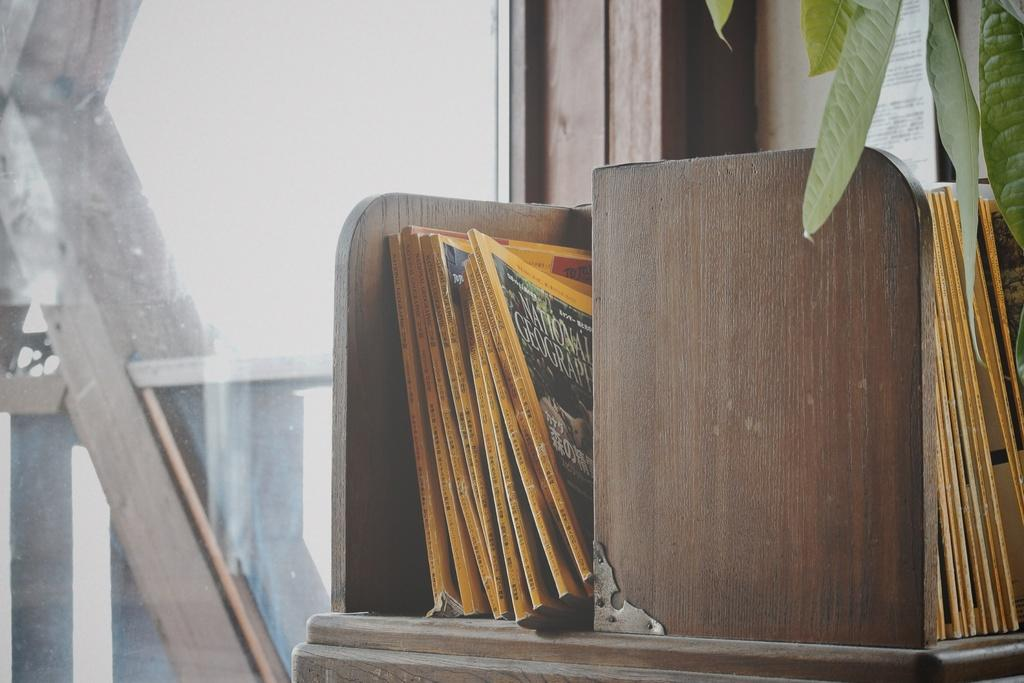What objects are located in the middle of the image? There are books in the middle of the image. What type of vegetation is present in the image? There are green leaves in the image. Where is the glass positioned in the image? The glass is on the left side of the image. How many spiders can be seen crawling on the books in the image? There are no spiders present in the image; it only features books, green leaves, and a glass. What type of roll is visible in the image? There is no roll present in the image. 